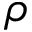Convert formula to latex. <formula><loc_0><loc_0><loc_500><loc_500>\rho</formula> 